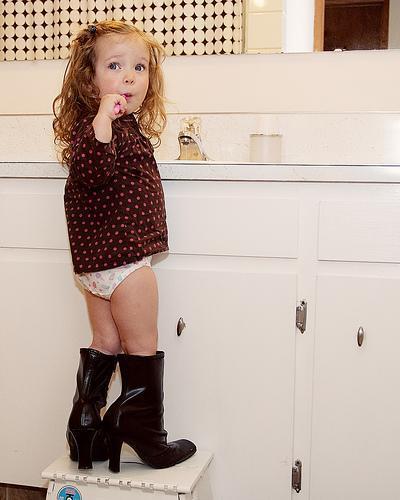How many people are there?
Give a very brief answer. 1. 